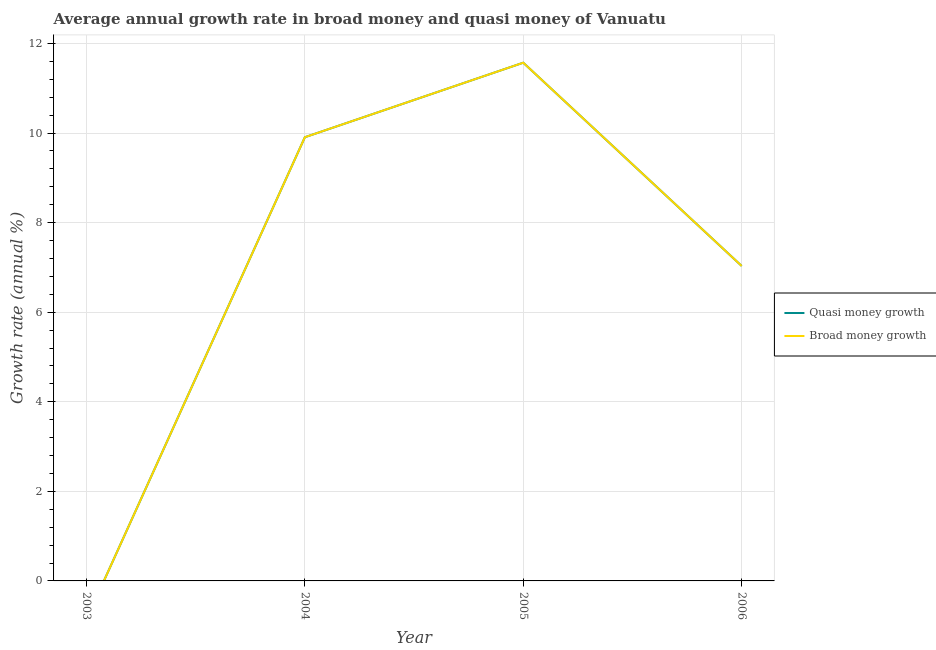How many different coloured lines are there?
Give a very brief answer. 2. Is the number of lines equal to the number of legend labels?
Your answer should be very brief. No. What is the annual growth rate in broad money in 2004?
Give a very brief answer. 9.91. Across all years, what is the maximum annual growth rate in quasi money?
Ensure brevity in your answer.  11.57. In which year was the annual growth rate in broad money maximum?
Keep it short and to the point. 2005. What is the total annual growth rate in quasi money in the graph?
Ensure brevity in your answer.  28.51. What is the difference between the annual growth rate in broad money in 2004 and that in 2005?
Give a very brief answer. -1.66. What is the difference between the annual growth rate in quasi money in 2003 and the annual growth rate in broad money in 2006?
Your answer should be very brief. -7.03. What is the average annual growth rate in broad money per year?
Make the answer very short. 7.13. In the year 2005, what is the difference between the annual growth rate in broad money and annual growth rate in quasi money?
Your answer should be compact. 0. In how many years, is the annual growth rate in broad money greater than 7.6 %?
Provide a short and direct response. 2. What is the ratio of the annual growth rate in quasi money in 2004 to that in 2005?
Offer a terse response. 0.86. Is the annual growth rate in broad money in 2004 less than that in 2006?
Your response must be concise. No. Is the difference between the annual growth rate in broad money in 2004 and 2006 greater than the difference between the annual growth rate in quasi money in 2004 and 2006?
Your response must be concise. No. What is the difference between the highest and the second highest annual growth rate in broad money?
Provide a succinct answer. 1.66. What is the difference between the highest and the lowest annual growth rate in quasi money?
Offer a very short reply. 11.57. In how many years, is the annual growth rate in quasi money greater than the average annual growth rate in quasi money taken over all years?
Offer a very short reply. 2. Does the annual growth rate in quasi money monotonically increase over the years?
Your response must be concise. No. Is the annual growth rate in broad money strictly greater than the annual growth rate in quasi money over the years?
Your response must be concise. No. Is the annual growth rate in broad money strictly less than the annual growth rate in quasi money over the years?
Keep it short and to the point. No. Does the graph contain any zero values?
Your response must be concise. Yes. Where does the legend appear in the graph?
Your response must be concise. Center right. How many legend labels are there?
Provide a succinct answer. 2. How are the legend labels stacked?
Offer a terse response. Vertical. What is the title of the graph?
Your response must be concise. Average annual growth rate in broad money and quasi money of Vanuatu. Does "Forest land" appear as one of the legend labels in the graph?
Keep it short and to the point. No. What is the label or title of the Y-axis?
Keep it short and to the point. Growth rate (annual %). What is the Growth rate (annual %) in Broad money growth in 2003?
Keep it short and to the point. 0. What is the Growth rate (annual %) in Quasi money growth in 2004?
Ensure brevity in your answer.  9.91. What is the Growth rate (annual %) of Broad money growth in 2004?
Ensure brevity in your answer.  9.91. What is the Growth rate (annual %) of Quasi money growth in 2005?
Provide a short and direct response. 11.57. What is the Growth rate (annual %) of Broad money growth in 2005?
Offer a very short reply. 11.57. What is the Growth rate (annual %) of Quasi money growth in 2006?
Ensure brevity in your answer.  7.03. What is the Growth rate (annual %) of Broad money growth in 2006?
Make the answer very short. 7.03. Across all years, what is the maximum Growth rate (annual %) in Quasi money growth?
Make the answer very short. 11.57. Across all years, what is the maximum Growth rate (annual %) of Broad money growth?
Provide a succinct answer. 11.57. Across all years, what is the minimum Growth rate (annual %) of Quasi money growth?
Your response must be concise. 0. What is the total Growth rate (annual %) of Quasi money growth in the graph?
Your answer should be compact. 28.51. What is the total Growth rate (annual %) in Broad money growth in the graph?
Make the answer very short. 28.51. What is the difference between the Growth rate (annual %) in Quasi money growth in 2004 and that in 2005?
Keep it short and to the point. -1.66. What is the difference between the Growth rate (annual %) in Broad money growth in 2004 and that in 2005?
Ensure brevity in your answer.  -1.66. What is the difference between the Growth rate (annual %) in Quasi money growth in 2004 and that in 2006?
Give a very brief answer. 2.87. What is the difference between the Growth rate (annual %) of Broad money growth in 2004 and that in 2006?
Your answer should be compact. 2.87. What is the difference between the Growth rate (annual %) in Quasi money growth in 2005 and that in 2006?
Keep it short and to the point. 4.54. What is the difference between the Growth rate (annual %) of Broad money growth in 2005 and that in 2006?
Your response must be concise. 4.54. What is the difference between the Growth rate (annual %) in Quasi money growth in 2004 and the Growth rate (annual %) in Broad money growth in 2005?
Keep it short and to the point. -1.66. What is the difference between the Growth rate (annual %) in Quasi money growth in 2004 and the Growth rate (annual %) in Broad money growth in 2006?
Provide a short and direct response. 2.87. What is the difference between the Growth rate (annual %) in Quasi money growth in 2005 and the Growth rate (annual %) in Broad money growth in 2006?
Offer a terse response. 4.54. What is the average Growth rate (annual %) in Quasi money growth per year?
Keep it short and to the point. 7.13. What is the average Growth rate (annual %) in Broad money growth per year?
Offer a very short reply. 7.13. In the year 2004, what is the difference between the Growth rate (annual %) in Quasi money growth and Growth rate (annual %) in Broad money growth?
Your answer should be very brief. 0. In the year 2005, what is the difference between the Growth rate (annual %) in Quasi money growth and Growth rate (annual %) in Broad money growth?
Keep it short and to the point. 0. What is the ratio of the Growth rate (annual %) in Quasi money growth in 2004 to that in 2005?
Provide a succinct answer. 0.86. What is the ratio of the Growth rate (annual %) in Broad money growth in 2004 to that in 2005?
Provide a succinct answer. 0.86. What is the ratio of the Growth rate (annual %) of Quasi money growth in 2004 to that in 2006?
Provide a short and direct response. 1.41. What is the ratio of the Growth rate (annual %) in Broad money growth in 2004 to that in 2006?
Give a very brief answer. 1.41. What is the ratio of the Growth rate (annual %) in Quasi money growth in 2005 to that in 2006?
Offer a very short reply. 1.65. What is the ratio of the Growth rate (annual %) in Broad money growth in 2005 to that in 2006?
Your response must be concise. 1.65. What is the difference between the highest and the second highest Growth rate (annual %) in Quasi money growth?
Provide a short and direct response. 1.66. What is the difference between the highest and the second highest Growth rate (annual %) in Broad money growth?
Your response must be concise. 1.66. What is the difference between the highest and the lowest Growth rate (annual %) of Quasi money growth?
Provide a short and direct response. 11.57. What is the difference between the highest and the lowest Growth rate (annual %) in Broad money growth?
Give a very brief answer. 11.57. 